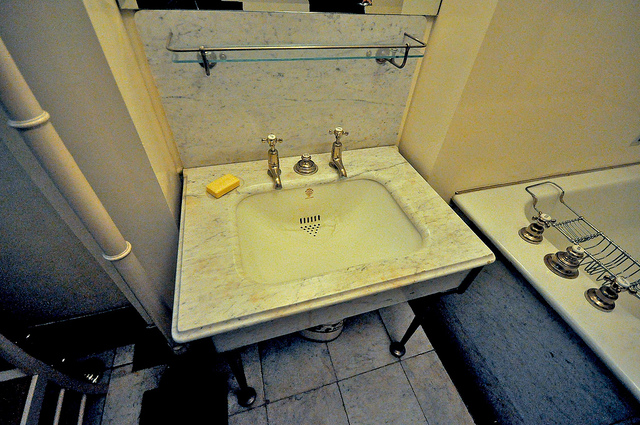Is there any evidence of water or moisture around the sink or bathtub? There is no visible evidence of water or moisture around the sink or bathtub. The surfaces appear dry and clean. 